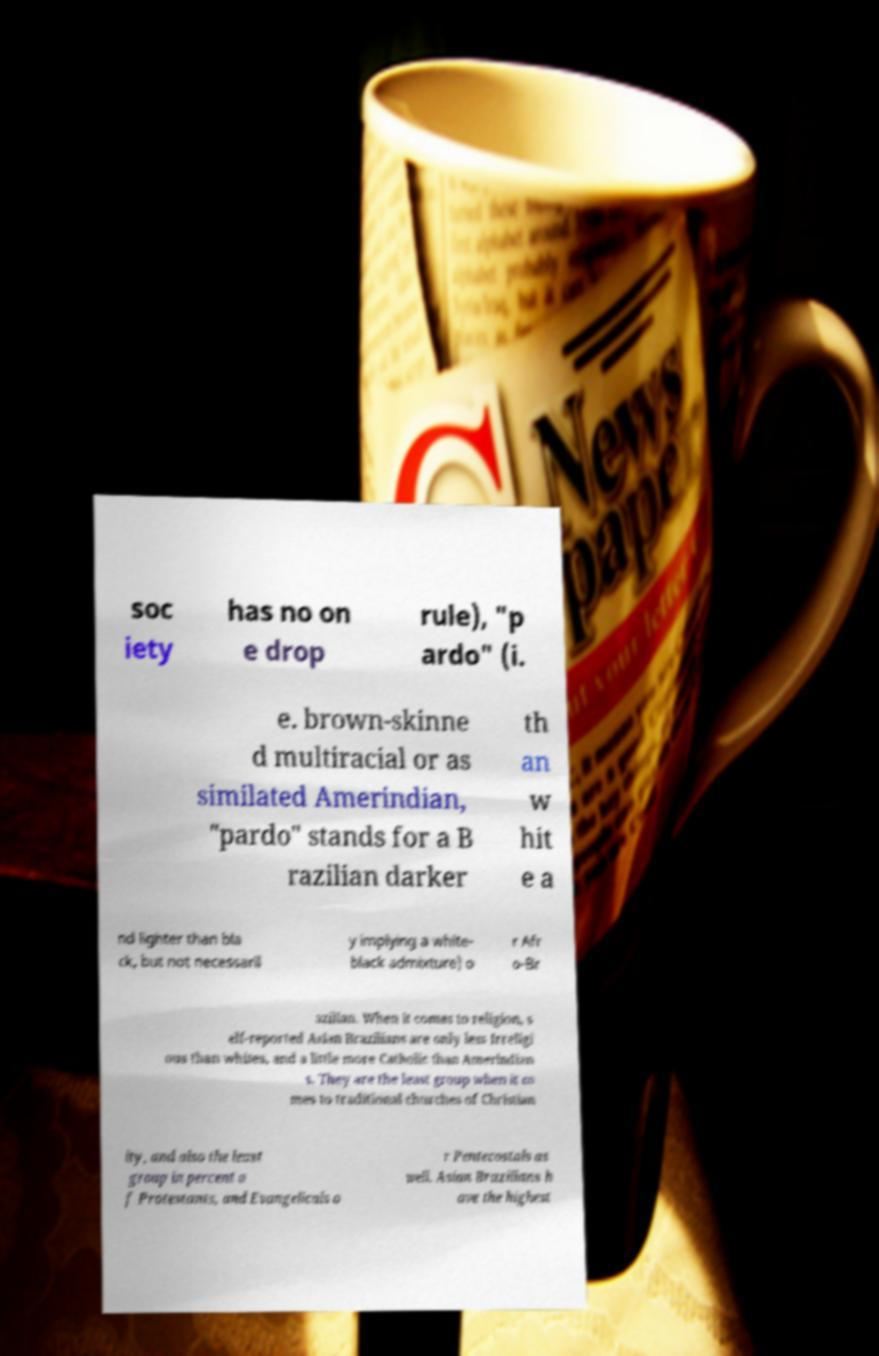Can you read and provide the text displayed in the image?This photo seems to have some interesting text. Can you extract and type it out for me? soc iety has no on e drop rule), "p ardo" (i. e. brown-skinne d multiracial or as similated Amerindian, "pardo" stands for a B razilian darker th an w hit e a nd lighter than bla ck, but not necessaril y implying a white- black admixture) o r Afr o-Br azilian. When it comes to religion, s elf-reported Asian Brazilians are only less Irreligi ous than whites, and a little more Catholic than Amerindian s. They are the least group when it co mes to traditional churches of Christian ity, and also the least group in percent o f Protestants, and Evangelicals o r Pentecostals as well. Asian Brazilians h ave the highest 